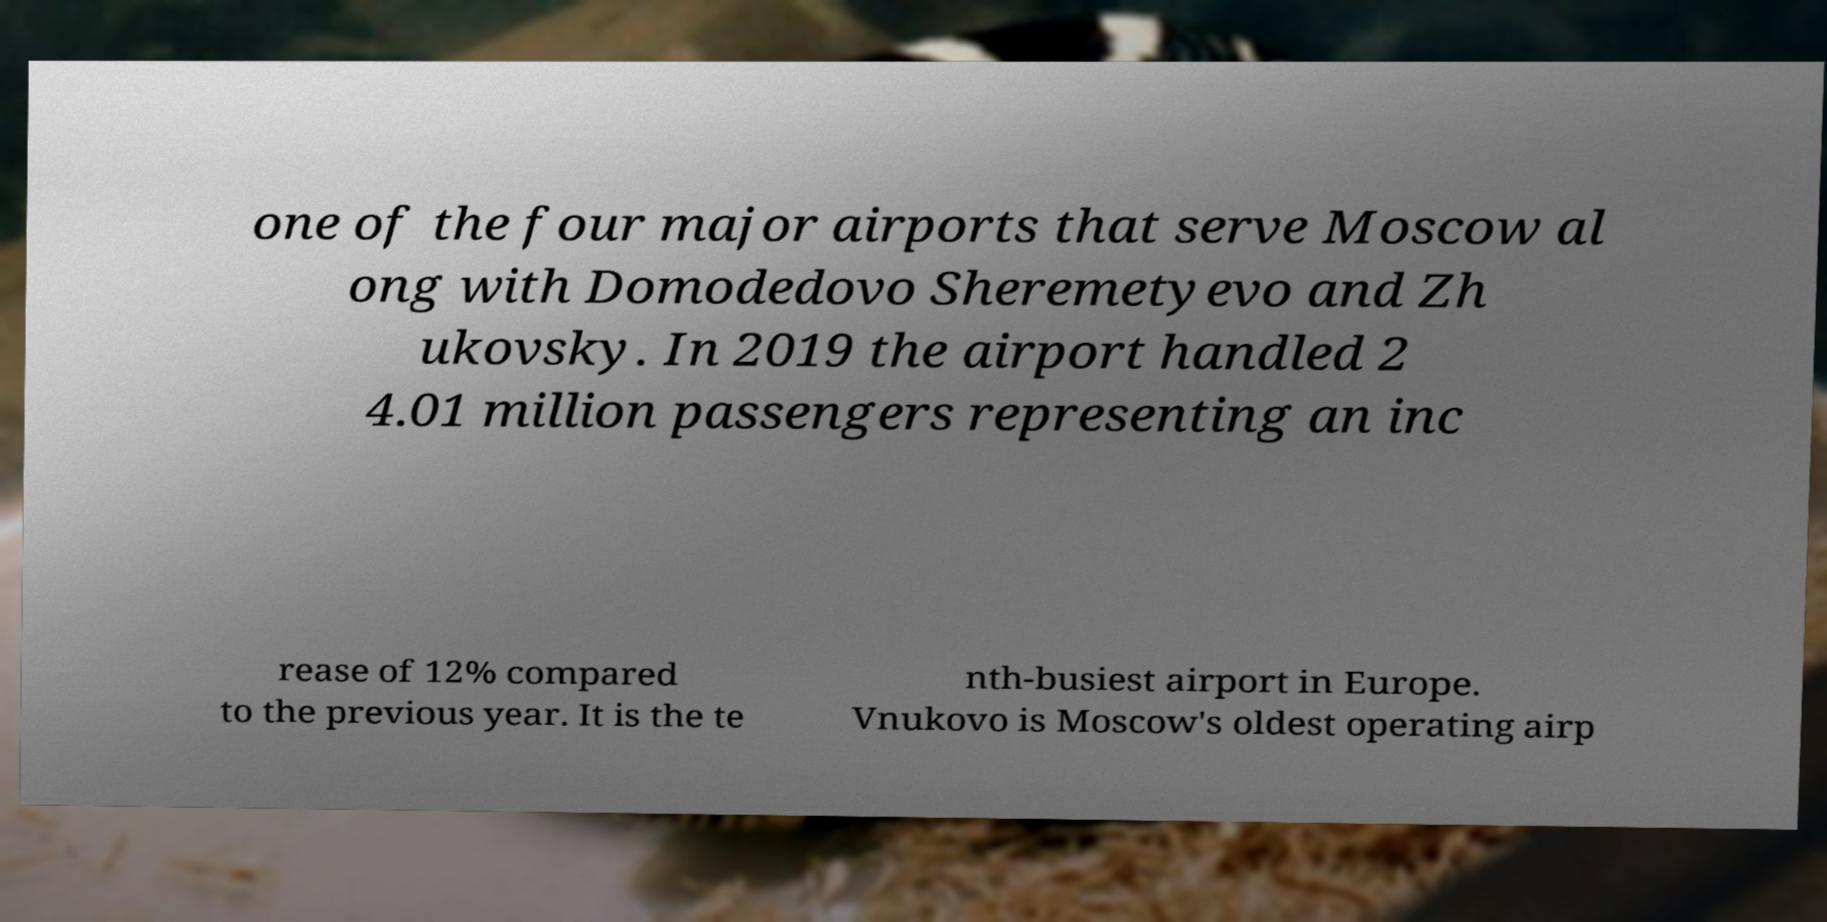For documentation purposes, I need the text within this image transcribed. Could you provide that? one of the four major airports that serve Moscow al ong with Domodedovo Sheremetyevo and Zh ukovsky. In 2019 the airport handled 2 4.01 million passengers representing an inc rease of 12% compared to the previous year. It is the te nth-busiest airport in Europe. Vnukovo is Moscow's oldest operating airp 